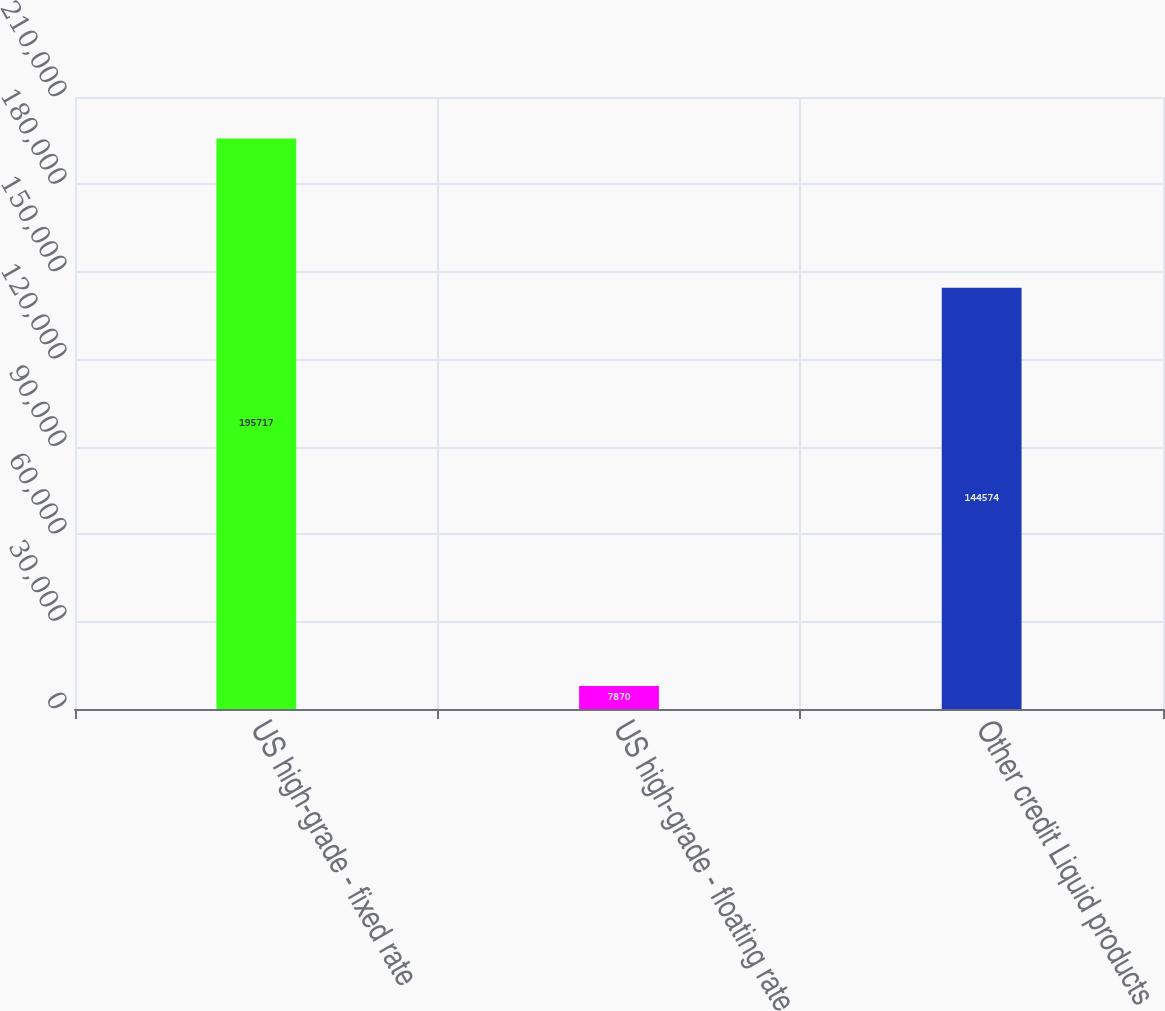<chart> <loc_0><loc_0><loc_500><loc_500><bar_chart><fcel>US high-grade - fixed rate<fcel>US high-grade - floating rate<fcel>Other credit Liquid products<nl><fcel>195717<fcel>7870<fcel>144574<nl></chart> 